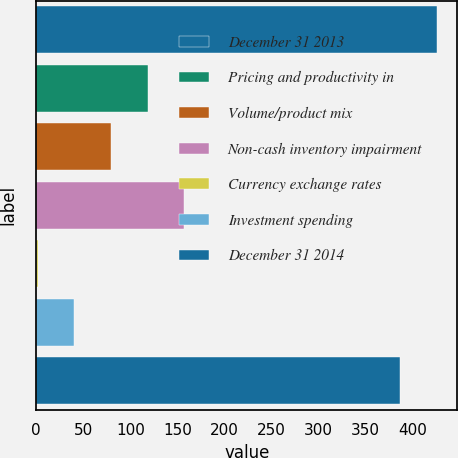<chart> <loc_0><loc_0><loc_500><loc_500><bar_chart><fcel>December 31 2013<fcel>Pricing and productivity in<fcel>Volume/product mix<fcel>Non-cash inventory impairment<fcel>Currency exchange rates<fcel>Investment spending<fcel>December 31 2014<nl><fcel>426.37<fcel>118.61<fcel>79.54<fcel>157.68<fcel>1.4<fcel>40.47<fcel>387.3<nl></chart> 